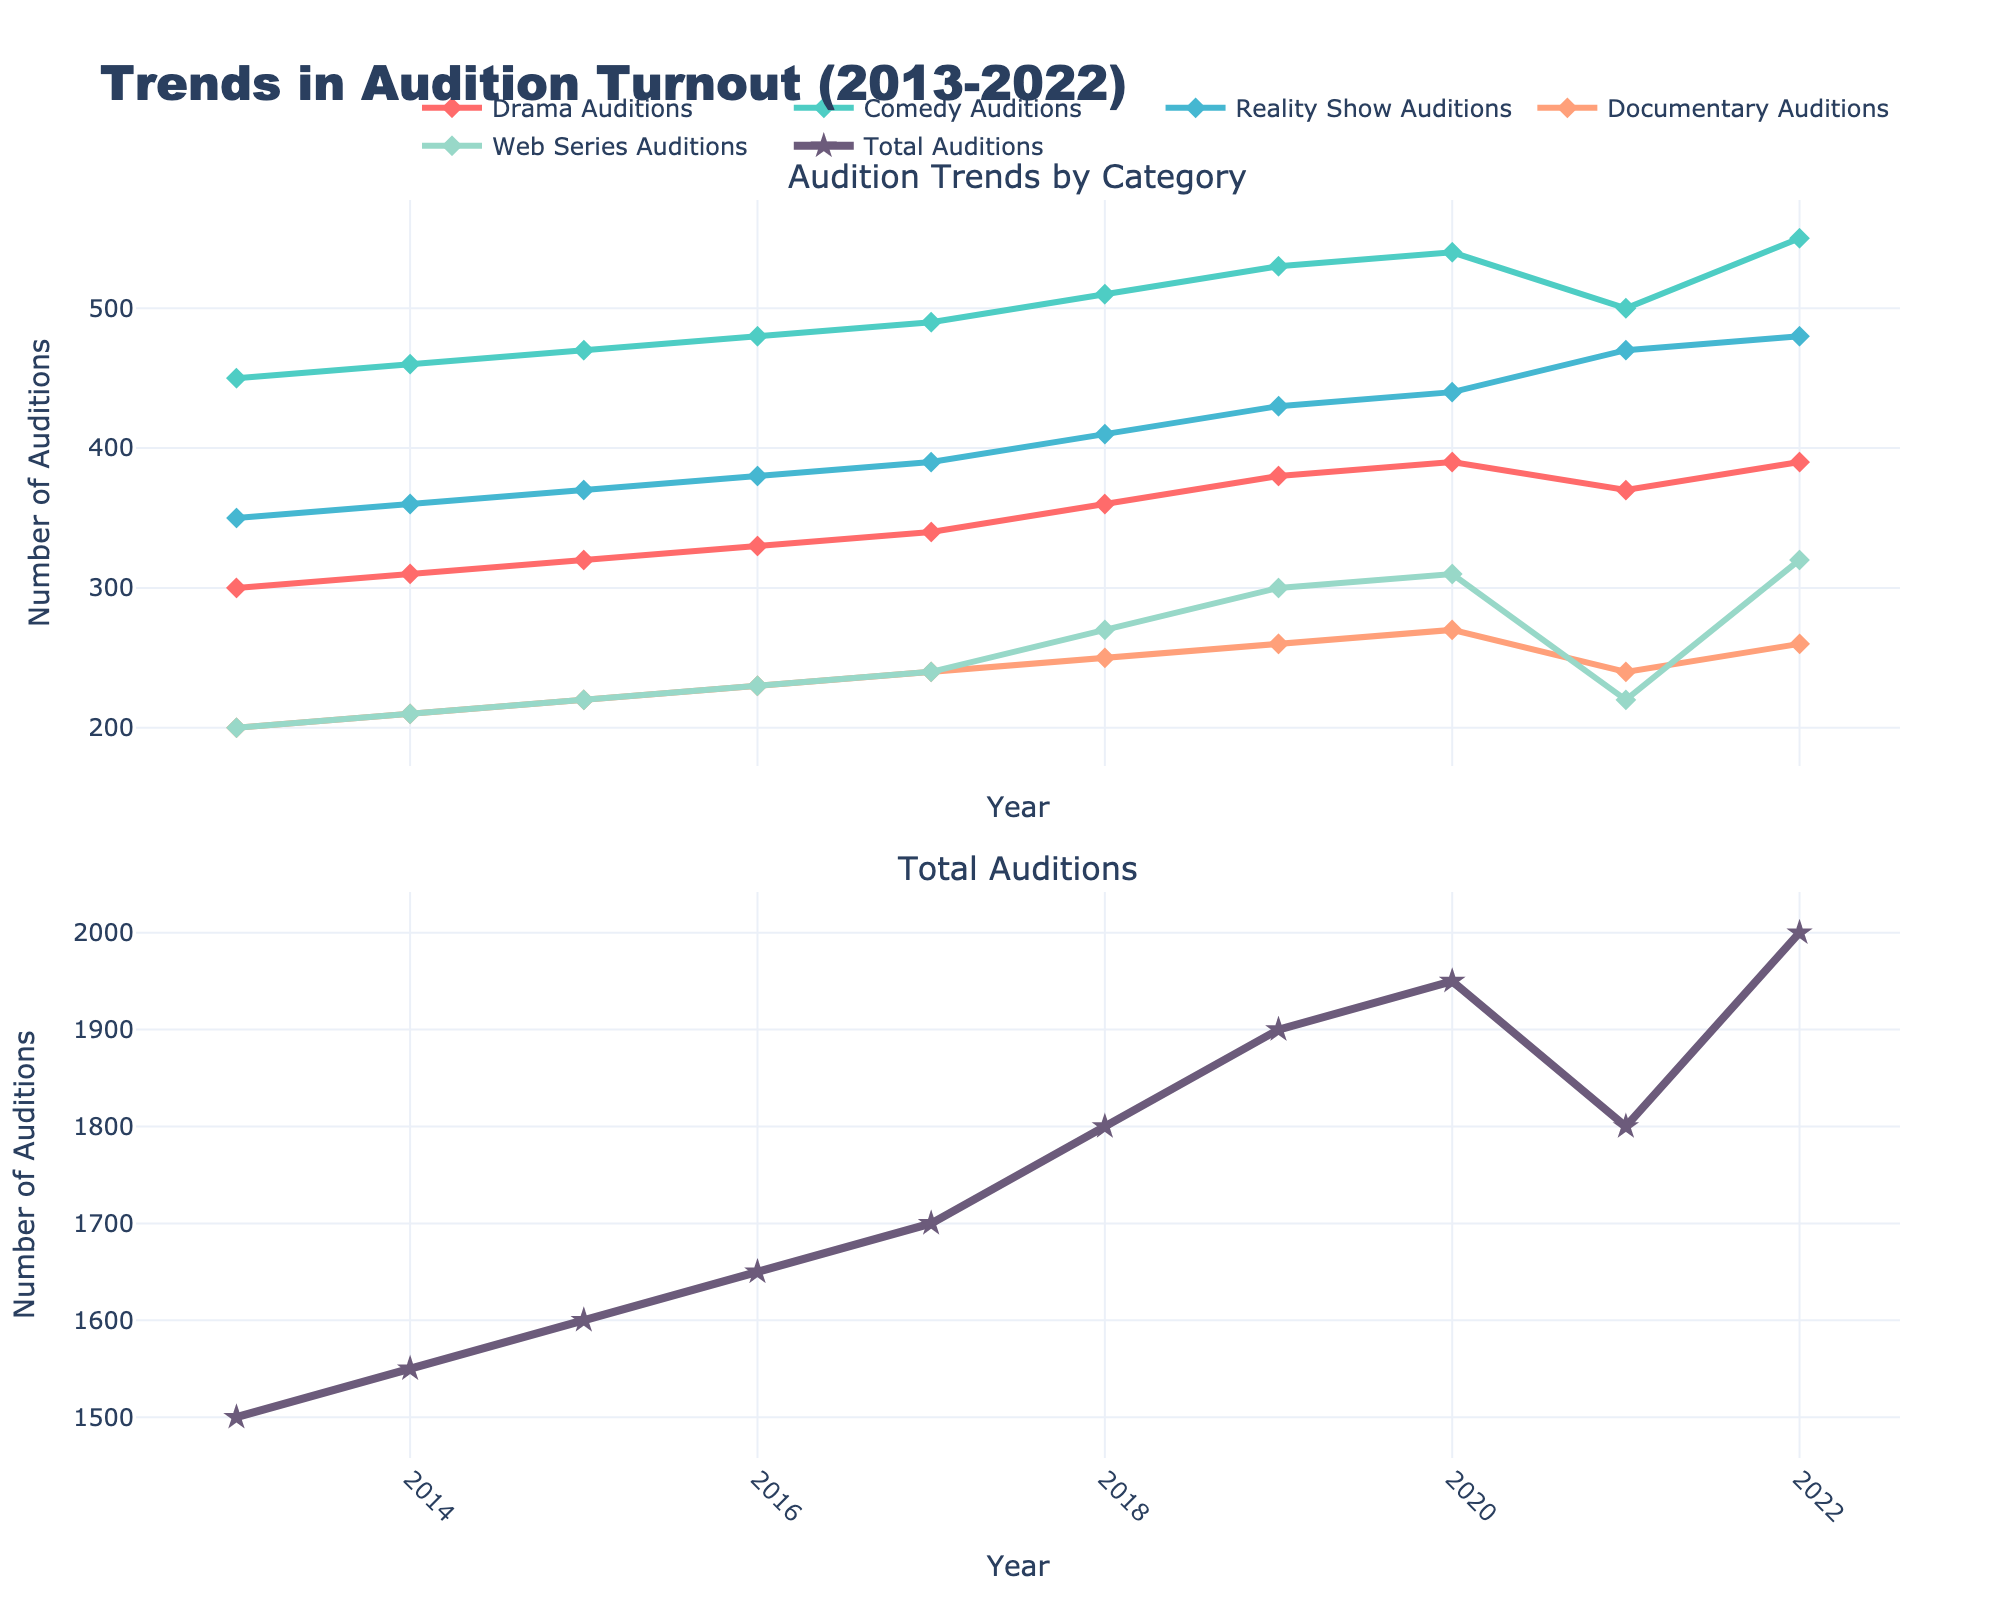What is the title of the figure? The title is located at the top of the figure and states the main subject being visualized.
Answer: Trends in Audition Turnout (2013-2022) Which category had the highest number of auditions in 2022? By looking at the values on the vertical axis and the trends for each line representing different categories, we can identify that Comedy Auditions had the highest number in 2022.
Answer: Comedy Auditions How many total auditions were there in 2017 and 2019 combined? To find this, add the total auditions for both years: 1700 (2017) + 1900 (2019) = 3600.
Answer: 3600 What was the general trend for documentary auditions between 2013 and 2022? By observing the line representing Documentary Auditions, we see that it increases steadily from 2013 to 2020 but fluctuates around a slightly decreasing trend post-2020.
Answer: Increased steadily then fluctuated Which year had the lowest turnout for Web Series Auditions? By identifying the lowest point on the line representing Web Series Auditions, we can see it is the year 2013.
Answer: 2013 In which year did Reality Show Auditions increase the most compared to the previous year? By comparing the height of the markers year-by-year, we find that the most significant increase occurred between 2021 (470) and 2022 (480).
Answer: 2022 What is the difference in the number of Drama Auditions between 2015 and 2021? The number of Drama Auditions in 2015 is 320 and in 2021 is 370. The difference is 370 - 320 = 50.
Answer: 50 How did the number of auditions for Comedy change from 2019 to 2020? By examining the Comedy Auditions line, the number increased from 530 in 2019 to 540 in 2020. The increment is 10.
Answer: Increased by 10 Did Web Series auditions show an overall increase or decrease from 2013 to 2022? By observing the overall trend of the Web Series Auditions line, it starts at 200 in 2013 and ends at 320 in 2022, indicating an increase.
Answer: Increase What was the trend in total auditions around 2020? By examining the Total Auditions line around 2020, we see a slight dip in 2021 and a subsequent increase in 2022, forming a small V-shaped pattern.
Answer: Small dip then increase 